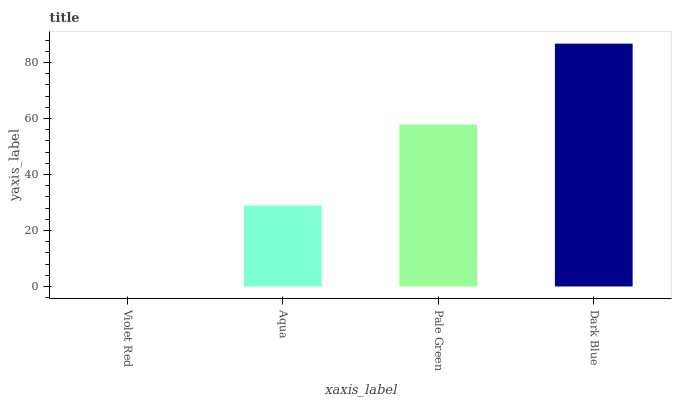Is Aqua the minimum?
Answer yes or no. No. Is Aqua the maximum?
Answer yes or no. No. Is Aqua greater than Violet Red?
Answer yes or no. Yes. Is Violet Red less than Aqua?
Answer yes or no. Yes. Is Violet Red greater than Aqua?
Answer yes or no. No. Is Aqua less than Violet Red?
Answer yes or no. No. Is Pale Green the high median?
Answer yes or no. Yes. Is Aqua the low median?
Answer yes or no. Yes. Is Violet Red the high median?
Answer yes or no. No. Is Pale Green the low median?
Answer yes or no. No. 